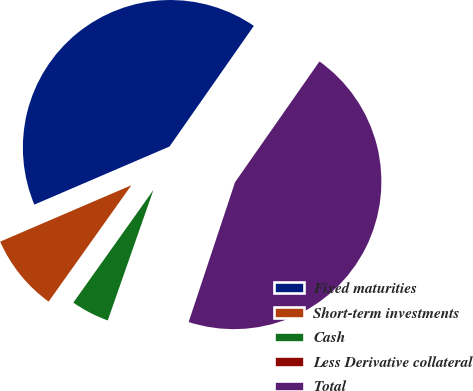Convert chart. <chart><loc_0><loc_0><loc_500><loc_500><pie_chart><fcel>Fixed maturities<fcel>Short-term investments<fcel>Cash<fcel>Less Derivative collateral<fcel>Total<nl><fcel>41.17%<fcel>8.7%<fcel>4.48%<fcel>0.26%<fcel>45.39%<nl></chart> 